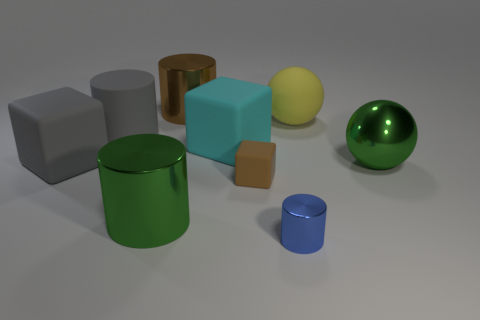Add 1 small purple matte spheres. How many objects exist? 10 Subtract 1 cylinders. How many cylinders are left? 3 Subtract all metal cylinders. How many cylinders are left? 1 Subtract all red cylinders. Subtract all yellow blocks. How many cylinders are left? 4 Subtract all balls. How many objects are left? 7 Subtract all rubber blocks. Subtract all small brown matte objects. How many objects are left? 5 Add 3 yellow rubber spheres. How many yellow rubber spheres are left? 4 Add 6 large cyan cubes. How many large cyan cubes exist? 7 Subtract 1 green cylinders. How many objects are left? 8 